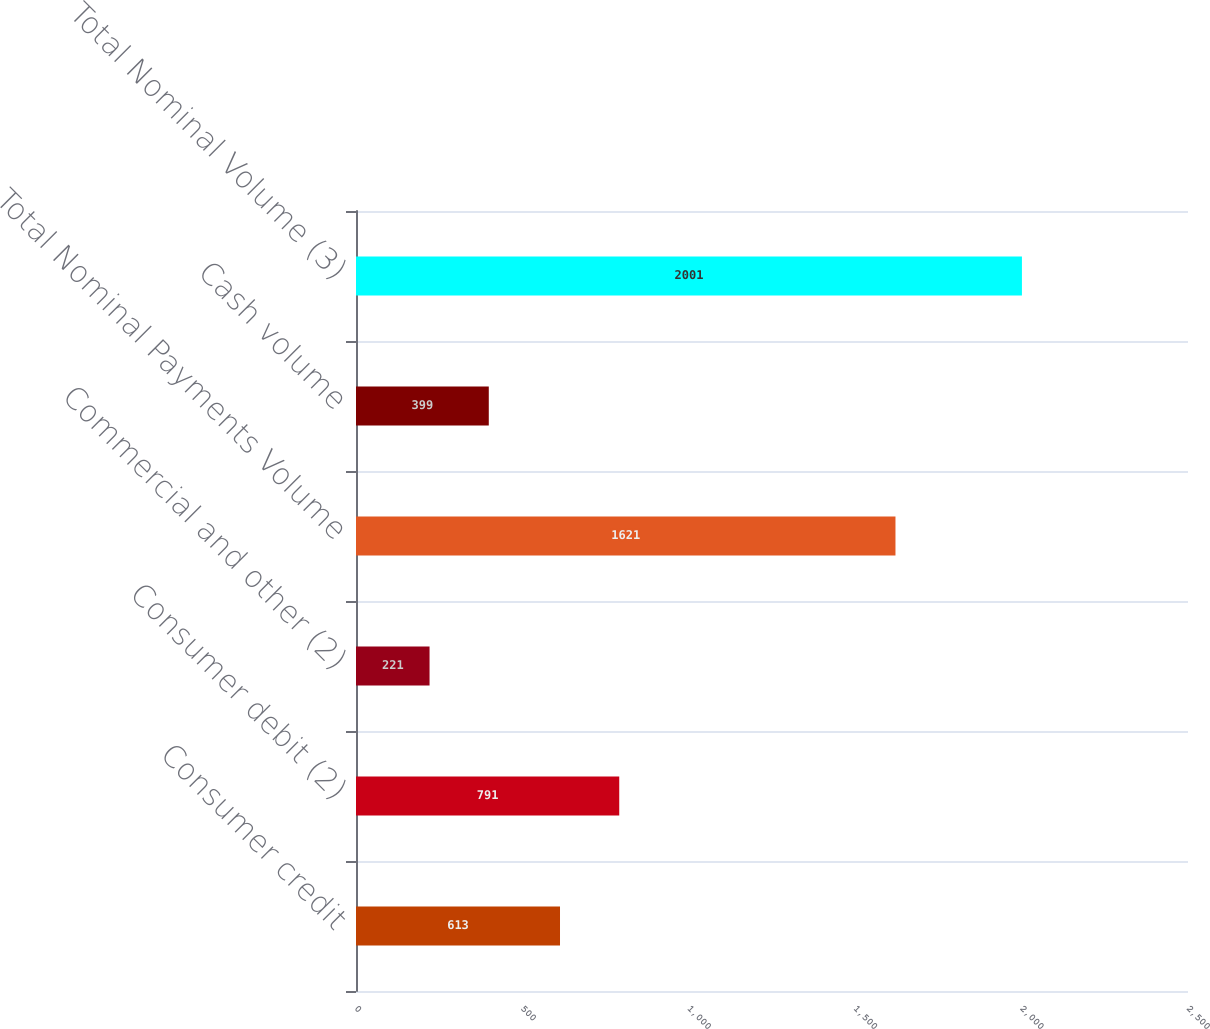Convert chart. <chart><loc_0><loc_0><loc_500><loc_500><bar_chart><fcel>Consumer credit<fcel>Consumer debit (2)<fcel>Commercial and other (2)<fcel>Total Nominal Payments Volume<fcel>Cash volume<fcel>Total Nominal Volume (3)<nl><fcel>613<fcel>791<fcel>221<fcel>1621<fcel>399<fcel>2001<nl></chart> 